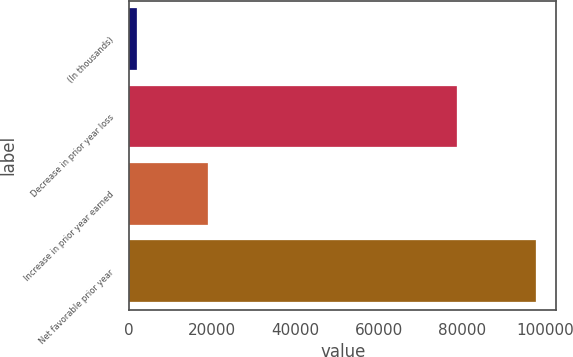Convert chart. <chart><loc_0><loc_0><loc_500><loc_500><bar_chart><fcel>(In thousands)<fcel>Decrease in prior year loss<fcel>Increase in prior year earned<fcel>Net favorable prior year<nl><fcel>2013<fcel>78810<fcel>19046<fcel>97856<nl></chart> 